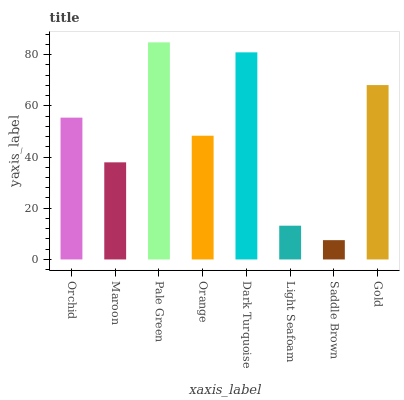Is Saddle Brown the minimum?
Answer yes or no. Yes. Is Pale Green the maximum?
Answer yes or no. Yes. Is Maroon the minimum?
Answer yes or no. No. Is Maroon the maximum?
Answer yes or no. No. Is Orchid greater than Maroon?
Answer yes or no. Yes. Is Maroon less than Orchid?
Answer yes or no. Yes. Is Maroon greater than Orchid?
Answer yes or no. No. Is Orchid less than Maroon?
Answer yes or no. No. Is Orchid the high median?
Answer yes or no. Yes. Is Orange the low median?
Answer yes or no. Yes. Is Gold the high median?
Answer yes or no. No. Is Saddle Brown the low median?
Answer yes or no. No. 